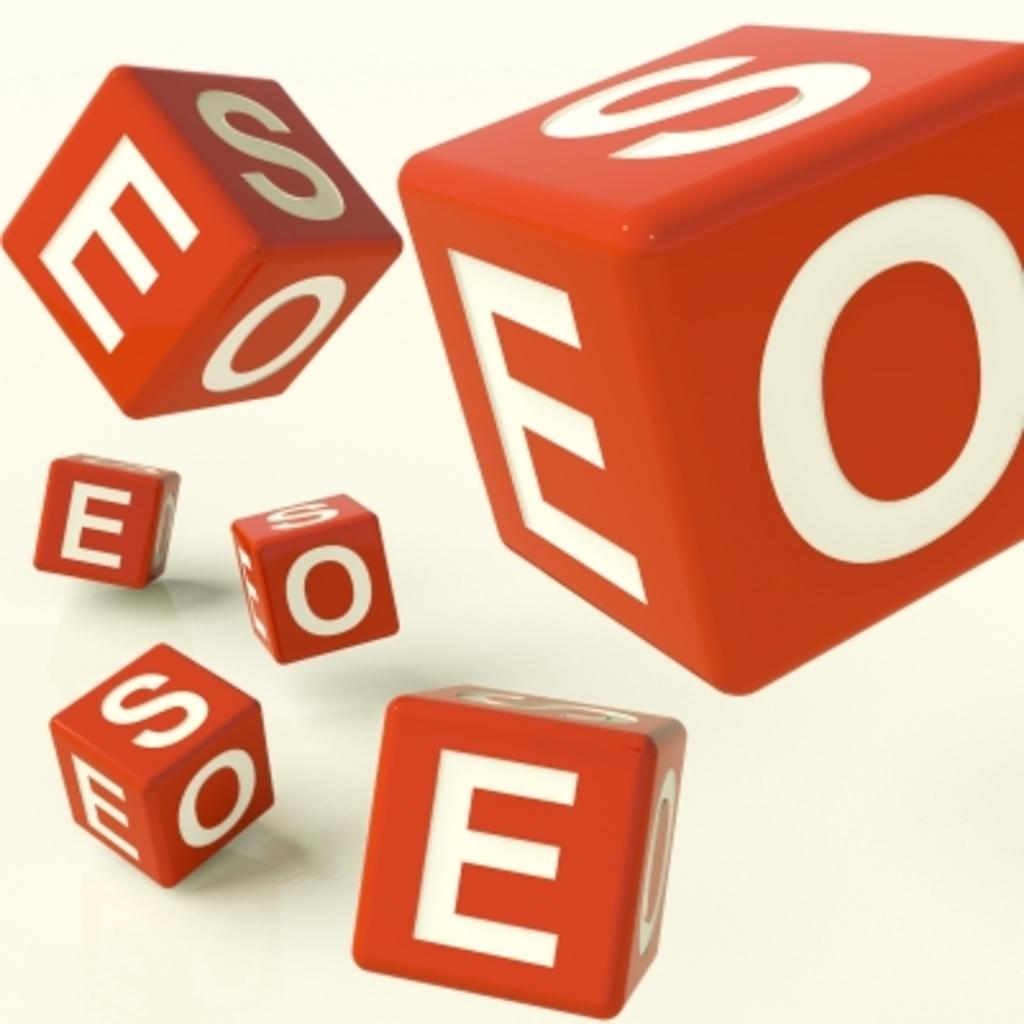Describe this image in one or two sentences. In this picture we can see dice, there are some letters on these dice, we can see a plane background. 